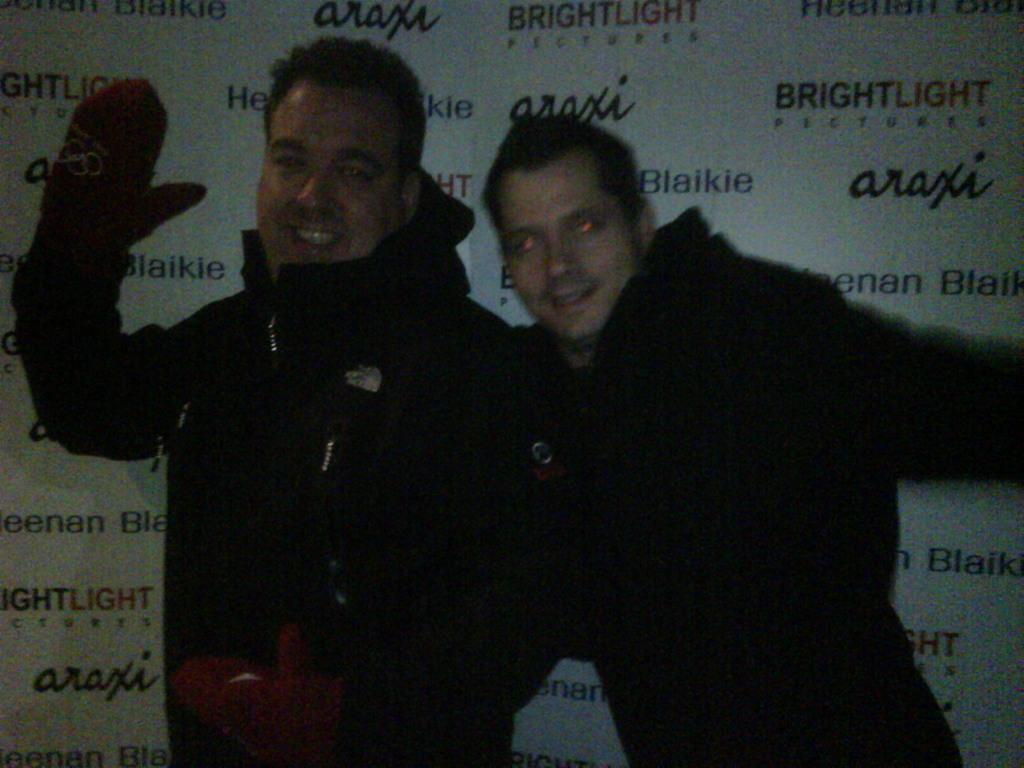In one or two sentences, can you explain what this image depicts? In this picture I can see there are two men standing and they are wearing black color coat, and the person at left is laughing and he is wearing a glove and in the backdrop there is a banner. 